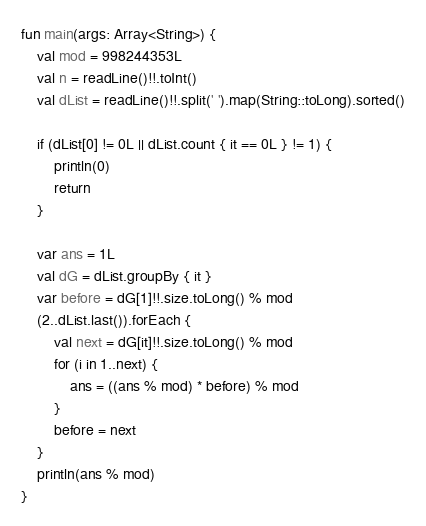<code> <loc_0><loc_0><loc_500><loc_500><_Kotlin_>fun main(args: Array<String>) {
    val mod = 998244353L
    val n = readLine()!!.toInt()
    val dList = readLine()!!.split(' ').map(String::toLong).sorted()

    if (dList[0] != 0L || dList.count { it == 0L } != 1) {
        println(0)
        return
    }

    var ans = 1L
    val dG = dList.groupBy { it }
    var before = dG[1]!!.size.toLong() % mod
    (2..dList.last()).forEach {
        val next = dG[it]!!.size.toLong() % mod
        for (i in 1..next) {
            ans = ((ans % mod) * before) % mod
        }
        before = next
    }
    println(ans % mod)
}</code> 